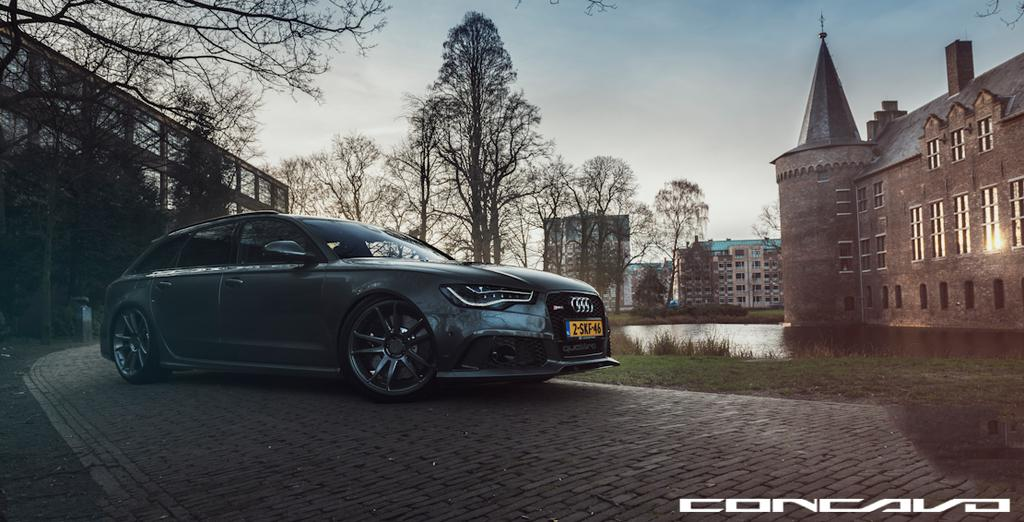What is the main subject of the image? There is a car on the road in the image. What else can be seen in the image besides the car? Water, buildings with windows, trees, and the sky are visible in the image. Can you describe the buildings in the image? The buildings have windows. What is the condition of the sky in the image? The sky is visible in the background of the image. How many knives are being used to cut the trees in the image? There are no knives present in the image, and no trees are being cut. What type of border can be seen surrounding the buildings in the image? There is no border surrounding the buildings in the image. 